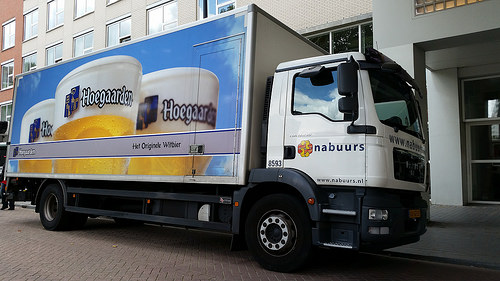<image>
Can you confirm if the window is on the truck? No. The window is not positioned on the truck. They may be near each other, but the window is not supported by or resting on top of the truck. 